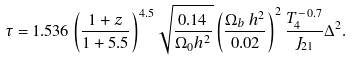Convert formula to latex. <formula><loc_0><loc_0><loc_500><loc_500>\tau = 1 . 5 3 6 \left ( \frac { 1 + z } { 1 + 5 . 5 } \right ) ^ { 4 . 5 } \sqrt { \frac { 0 . 1 4 } { \Omega _ { 0 } h ^ { 2 } } } \left ( \frac { \Omega _ { b } \, h ^ { 2 } } { 0 . 0 2 } \right ) ^ { 2 } \frac { T _ { 4 } ^ { - 0 . 7 } } { J _ { 2 1 } } \Delta ^ { 2 } .</formula> 